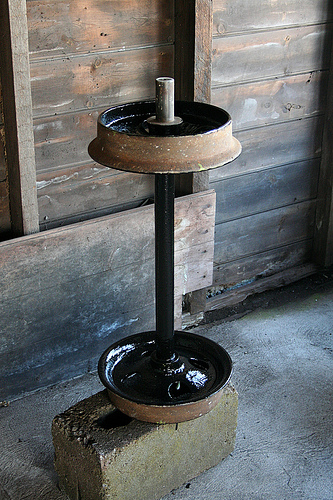<image>
Can you confirm if the weight is on the wall? No. The weight is not positioned on the wall. They may be near each other, but the weight is not supported by or resting on top of the wall. 